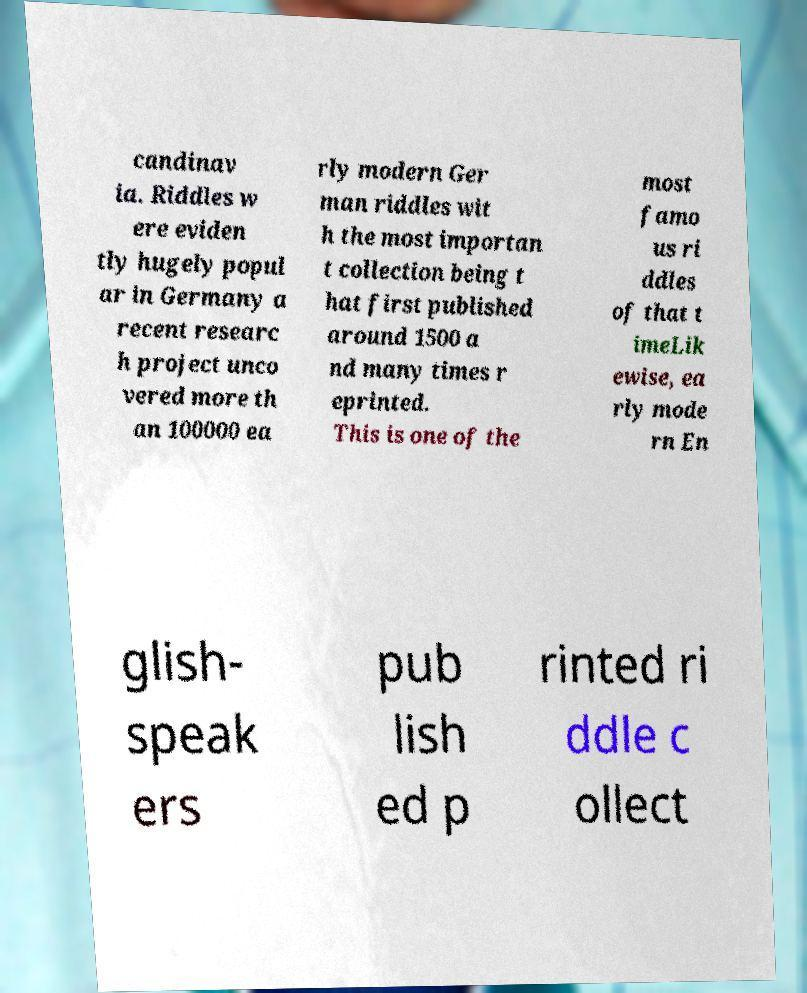I need the written content from this picture converted into text. Can you do that? candinav ia. Riddles w ere eviden tly hugely popul ar in Germany a recent researc h project unco vered more th an 100000 ea rly modern Ger man riddles wit h the most importan t collection being t hat first published around 1500 a nd many times r eprinted. This is one of the most famo us ri ddles of that t imeLik ewise, ea rly mode rn En glish- speak ers pub lish ed p rinted ri ddle c ollect 